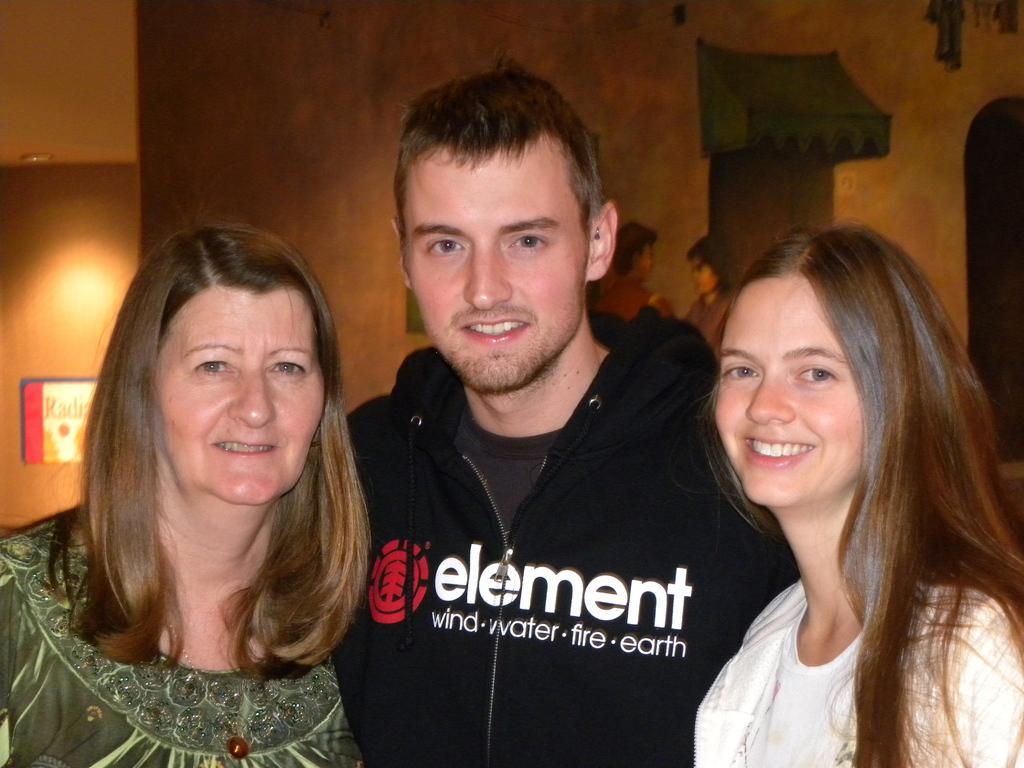Can you describe this image briefly? In this picture I can see a man and two women, in the background there is a painting on the wall. On the left side I can see a board on the wall. 